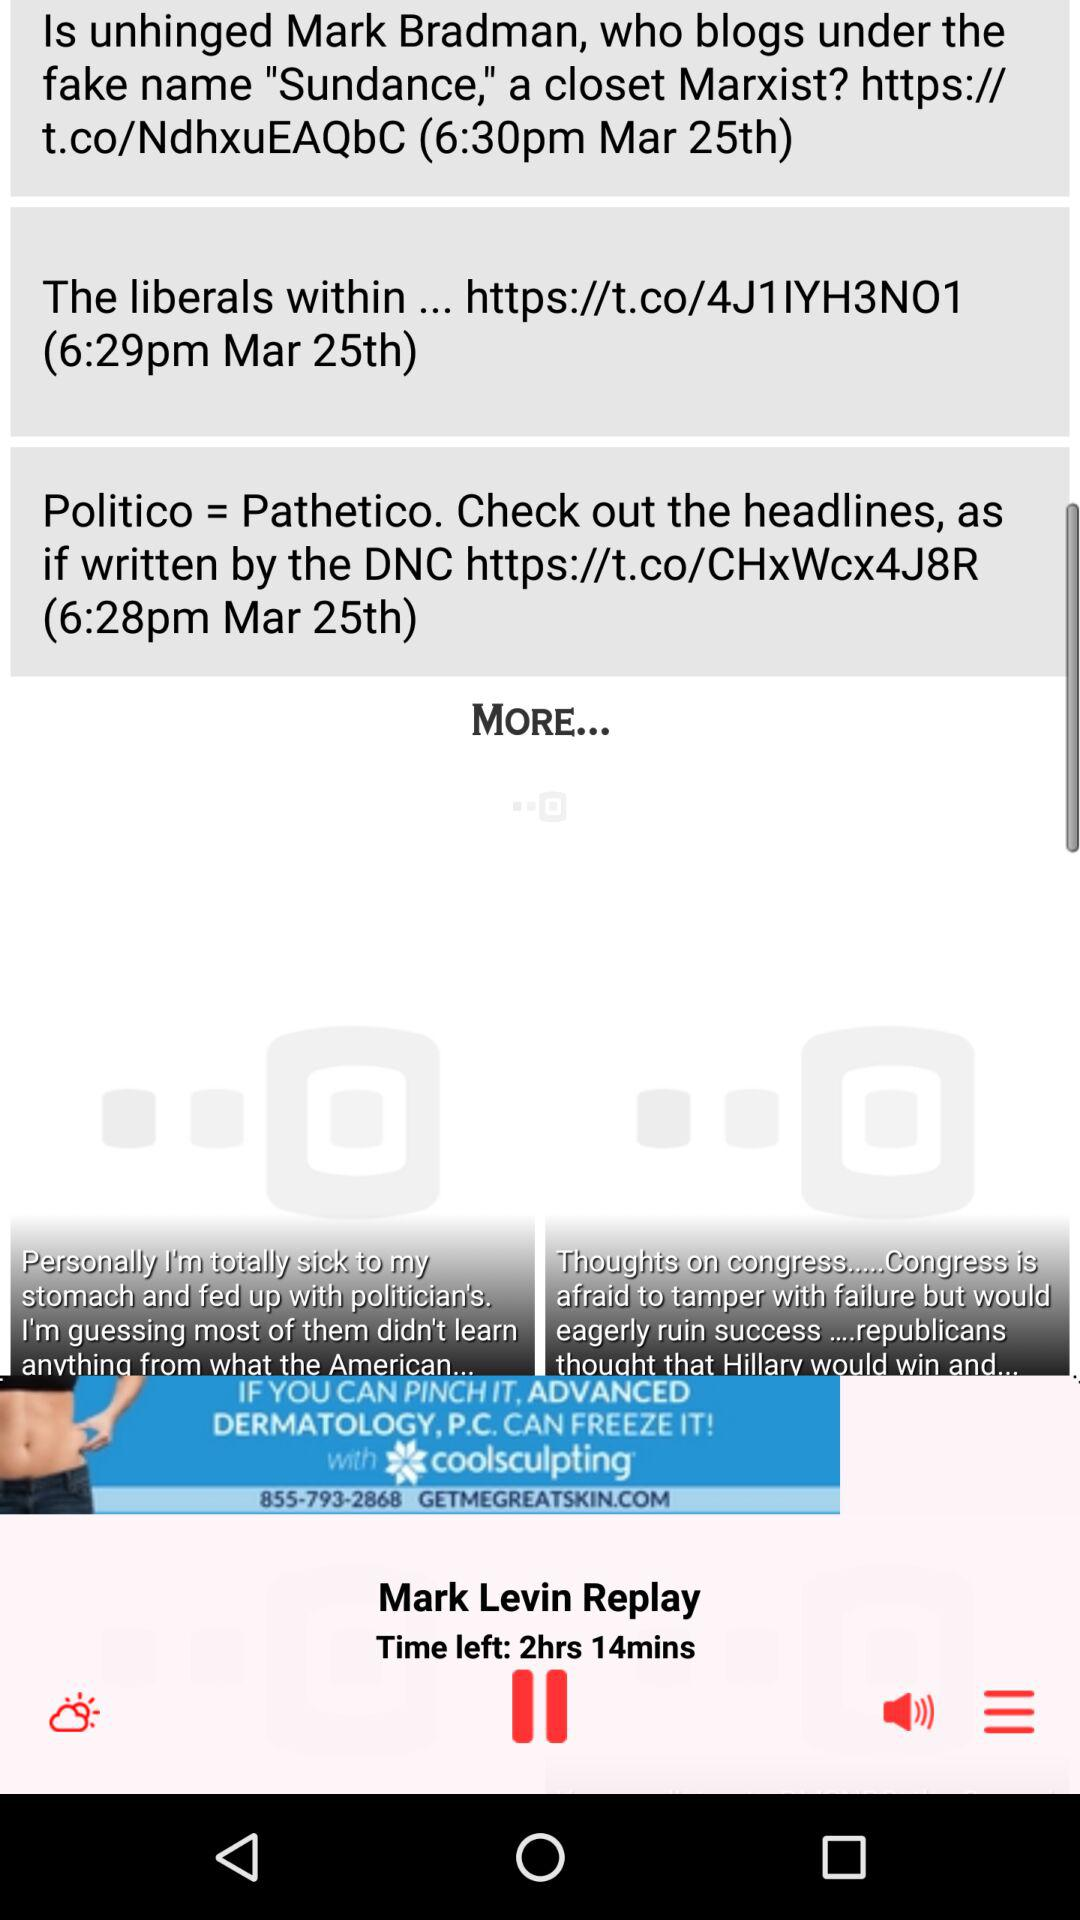What's the name of the currently playing audio? The name is "Mark Levin Replay". 